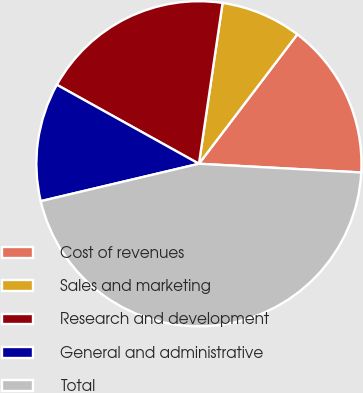Convert chart. <chart><loc_0><loc_0><loc_500><loc_500><pie_chart><fcel>Cost of revenues<fcel>Sales and marketing<fcel>Research and development<fcel>General and administrative<fcel>Total<nl><fcel>15.51%<fcel>8.02%<fcel>19.25%<fcel>11.77%<fcel>45.45%<nl></chart> 